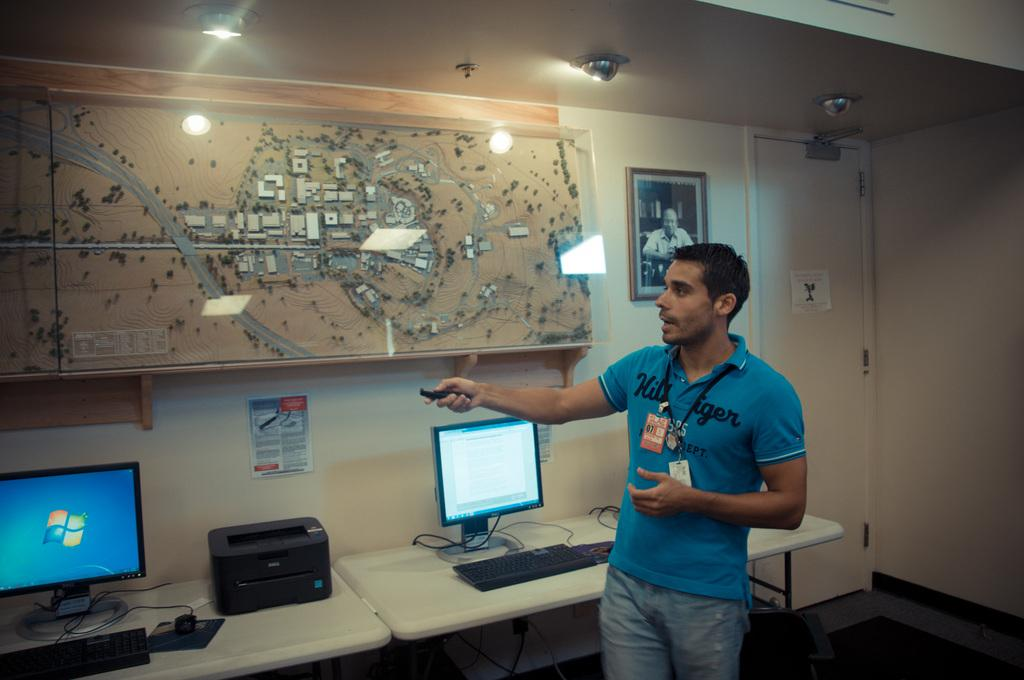<image>
Present a compact description of the photo's key features. A man in a blue shirt with Hil on the upper left front side points a remote. 